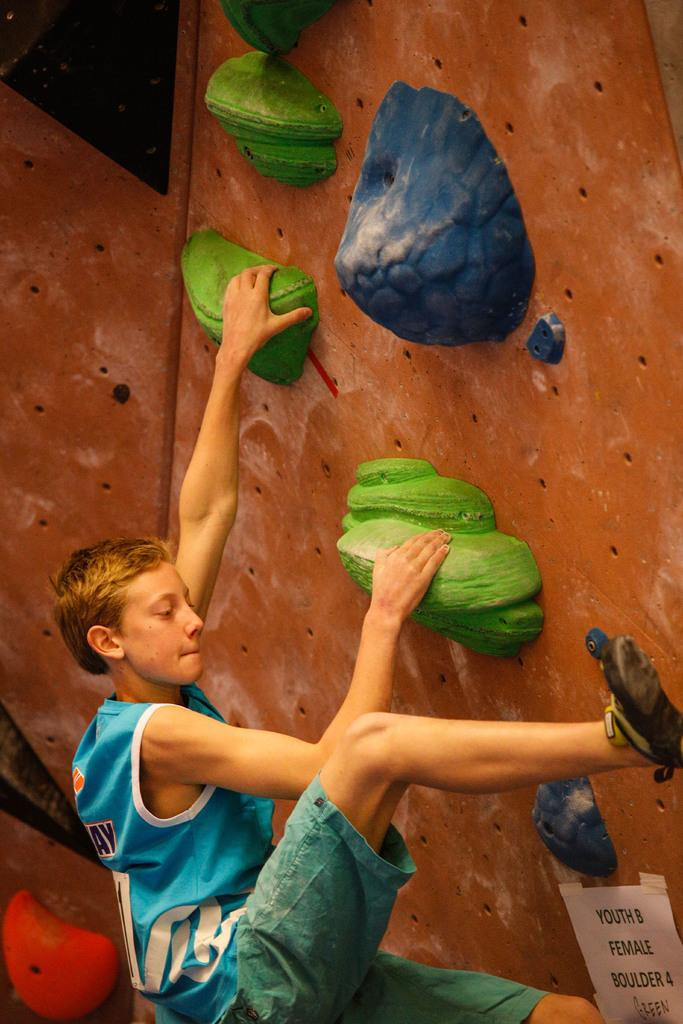What is present in the image? There is a person in the image. What is the person wearing? The person is wearing clothes. What action is the person performing in the image? The person is climbing a wall. What type of slope can be seen in the image? There is no slope present in the image; it features a person climbing a wall. Where is the seat located in the image? There is no seat present in the image. 